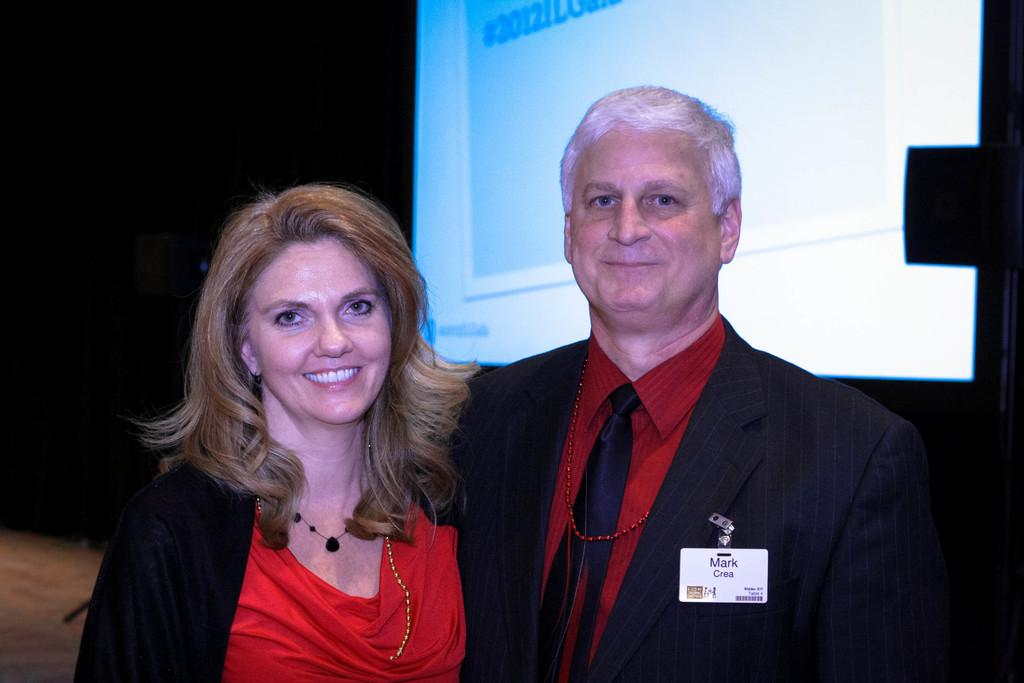What can be seen in the front of the image? There are persons standing in the front of the image. How are the persons in the image expressing themselves? The persons are smiling. What is located in the background of the image? There is a screen in the background of the image. What is displayed on the screen? The screen displays numbers. Can you hear the persons in the image coughing? There is no auditory information provided in the image, so it cannot be determined if the persons are coughing or not. What type of stamp is visible on the screen in the image? There is no stamp present on the screen in the image; it displays numbers. 